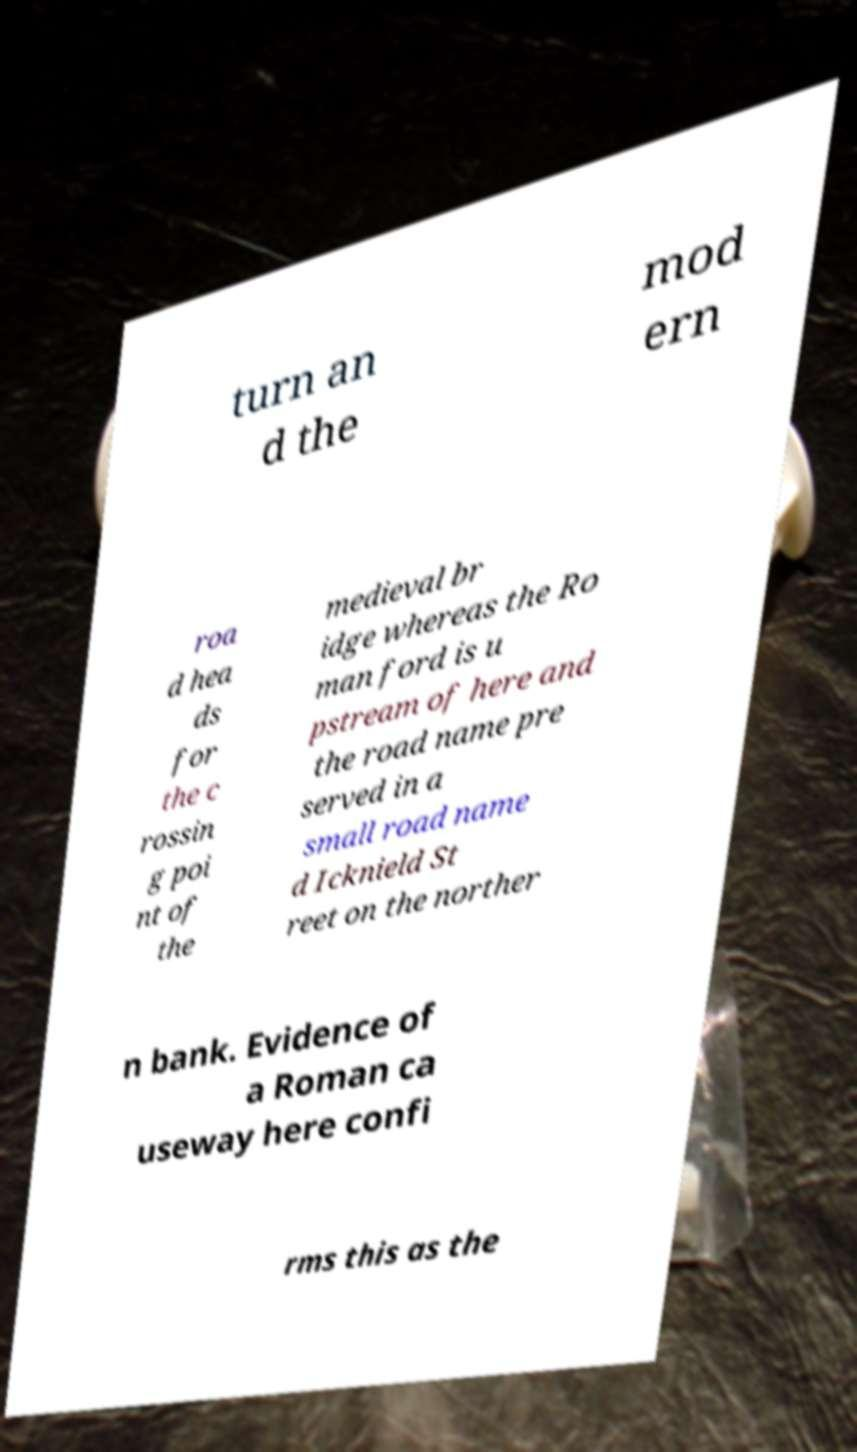What messages or text are displayed in this image? I need them in a readable, typed format. turn an d the mod ern roa d hea ds for the c rossin g poi nt of the medieval br idge whereas the Ro man ford is u pstream of here and the road name pre served in a small road name d Icknield St reet on the norther n bank. Evidence of a Roman ca useway here confi rms this as the 